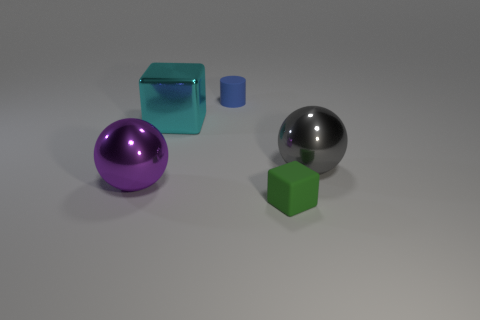Add 1 gray spheres. How many objects exist? 6 Subtract all blocks. How many objects are left? 3 Add 5 green cubes. How many green cubes are left? 6 Add 4 blue cylinders. How many blue cylinders exist? 5 Subtract 0 blue cubes. How many objects are left? 5 Subtract all large purple shiny things. Subtract all large brown metal blocks. How many objects are left? 4 